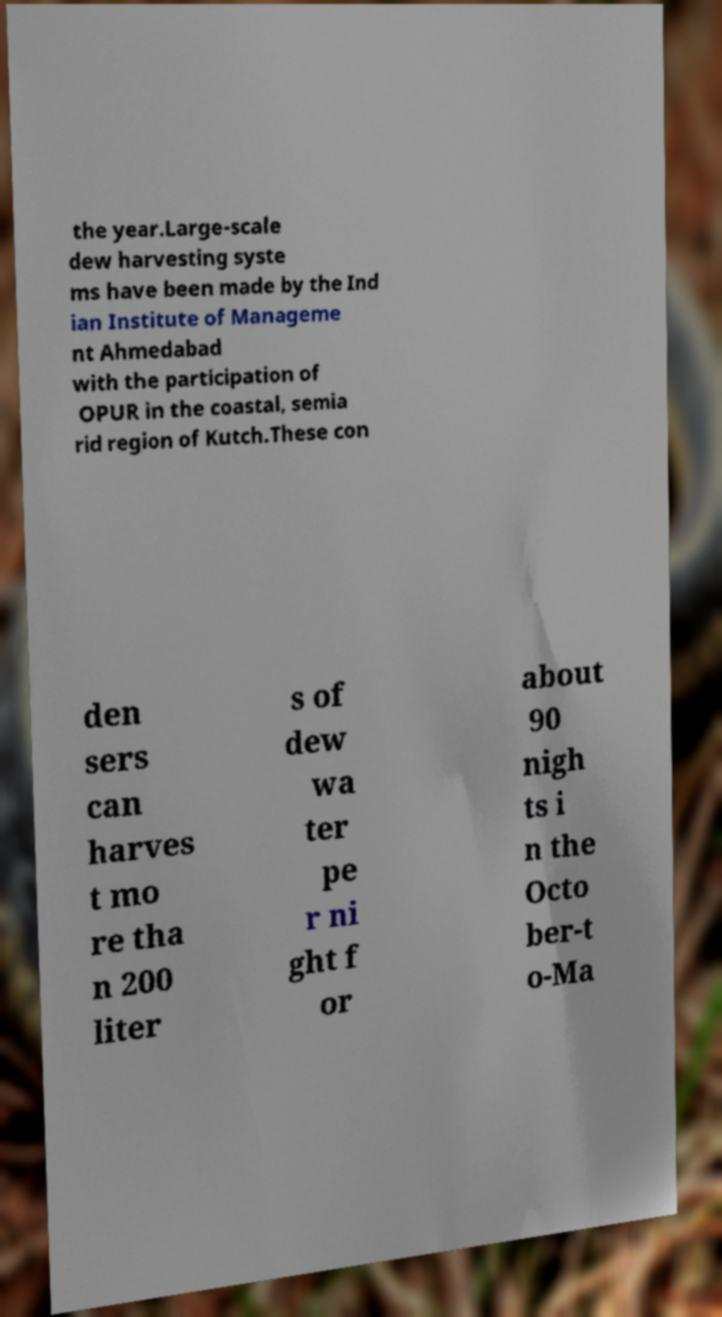Please identify and transcribe the text found in this image. the year.Large-scale dew harvesting syste ms have been made by the Ind ian Institute of Manageme nt Ahmedabad with the participation of OPUR in the coastal, semia rid region of Kutch.These con den sers can harves t mo re tha n 200 liter s of dew wa ter pe r ni ght f or about 90 nigh ts i n the Octo ber-t o-Ma 